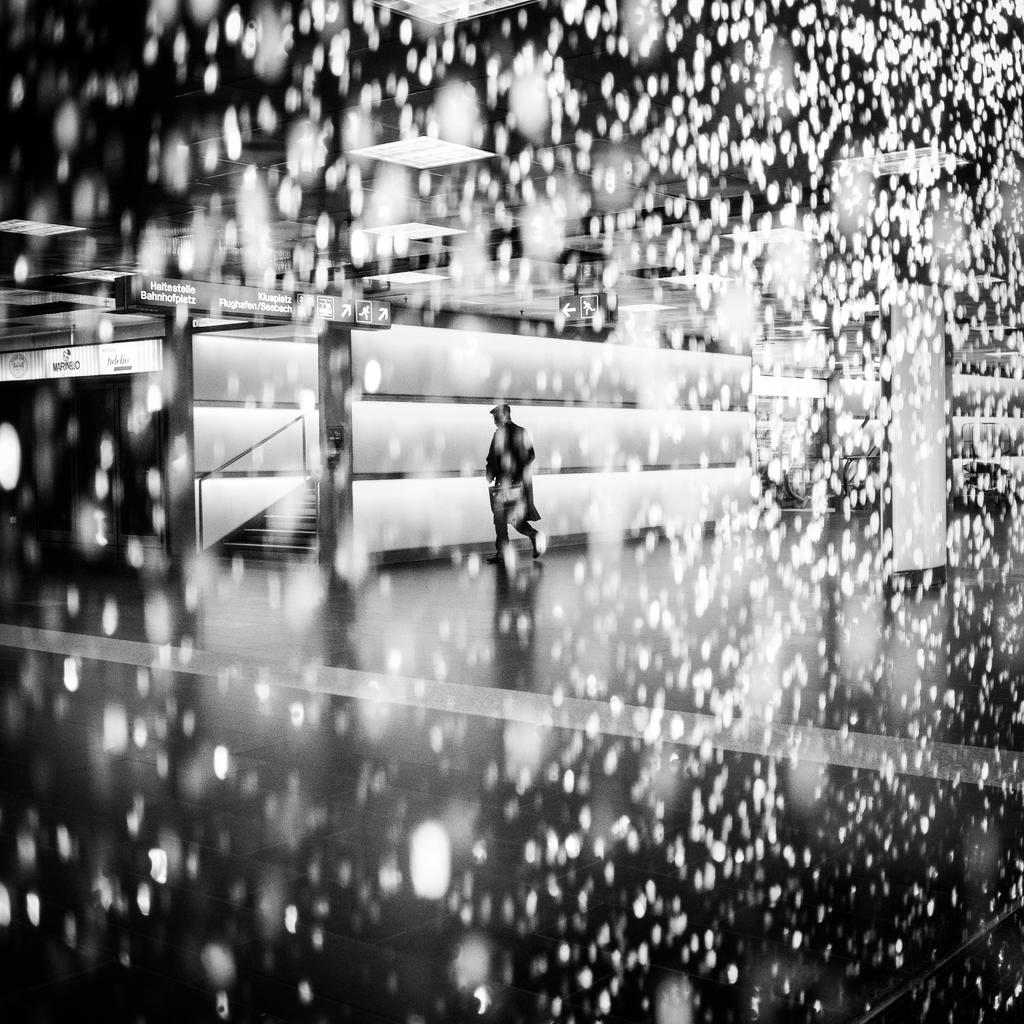What is the main subject of the image? There is a person standing in the middle of the image. Can you tell if the image has been altered in any way? Yes, the image has been edited. What is at the bottom of the image? There is a floor at the bottom of the image. What can be seen in the background of the image? There is a building in the background of the image. What type of knot is being tied by the government in the image? There is no knot or government present in the image; it features a person standing in an edited image with a floor and a building in the background. 